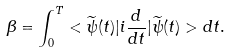Convert formula to latex. <formula><loc_0><loc_0><loc_500><loc_500>\beta = \int ^ { T } _ { 0 } < \widetilde { \psi } ( t ) | i \frac { d } { d t } | \widetilde { \psi } ( t ) > d t .</formula> 